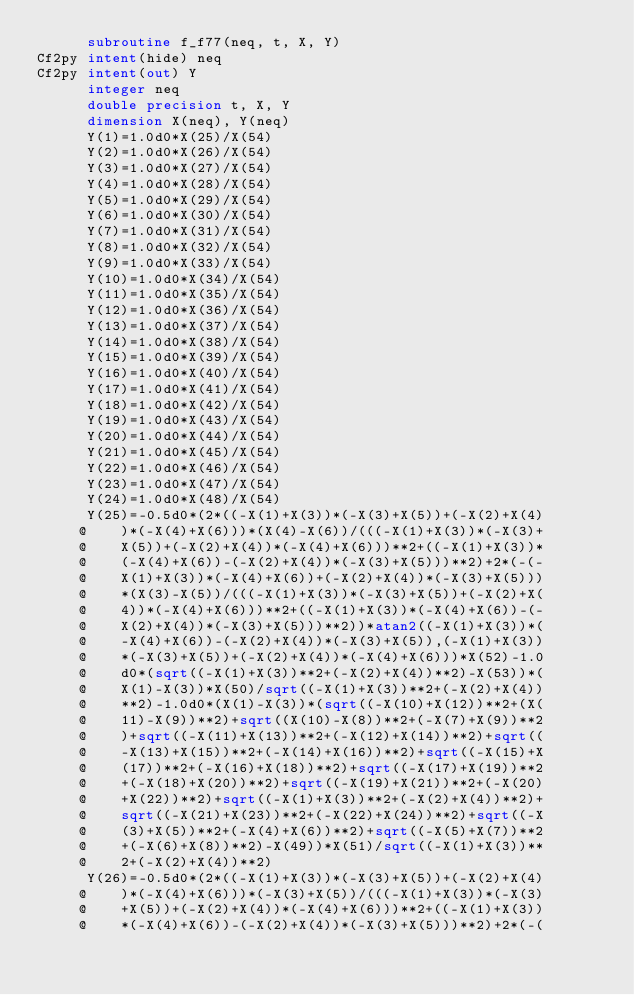<code> <loc_0><loc_0><loc_500><loc_500><_FORTRAN_>      subroutine f_f77(neq, t, X, Y)
Cf2py intent(hide) neq
Cf2py intent(out) Y
      integer neq
      double precision t, X, Y
      dimension X(neq), Y(neq)
      Y(1)=1.0d0*X(25)/X(54)
      Y(2)=1.0d0*X(26)/X(54)
      Y(3)=1.0d0*X(27)/X(54)
      Y(4)=1.0d0*X(28)/X(54)
      Y(5)=1.0d0*X(29)/X(54)
      Y(6)=1.0d0*X(30)/X(54)
      Y(7)=1.0d0*X(31)/X(54)
      Y(8)=1.0d0*X(32)/X(54)
      Y(9)=1.0d0*X(33)/X(54)
      Y(10)=1.0d0*X(34)/X(54)
      Y(11)=1.0d0*X(35)/X(54)
      Y(12)=1.0d0*X(36)/X(54)
      Y(13)=1.0d0*X(37)/X(54)
      Y(14)=1.0d0*X(38)/X(54)
      Y(15)=1.0d0*X(39)/X(54)
      Y(16)=1.0d0*X(40)/X(54)
      Y(17)=1.0d0*X(41)/X(54)
      Y(18)=1.0d0*X(42)/X(54)
      Y(19)=1.0d0*X(43)/X(54)
      Y(20)=1.0d0*X(44)/X(54)
      Y(21)=1.0d0*X(45)/X(54)
      Y(22)=1.0d0*X(46)/X(54)
      Y(23)=1.0d0*X(47)/X(54)
      Y(24)=1.0d0*X(48)/X(54)
      Y(25)=-0.5d0*(2*((-X(1)+X(3))*(-X(3)+X(5))+(-X(2)+X(4)
     @    )*(-X(4)+X(6)))*(X(4)-X(6))/(((-X(1)+X(3))*(-X(3)+
     @    X(5))+(-X(2)+X(4))*(-X(4)+X(6)))**2+((-X(1)+X(3))*
     @    (-X(4)+X(6))-(-X(2)+X(4))*(-X(3)+X(5)))**2)+2*(-(-
     @    X(1)+X(3))*(-X(4)+X(6))+(-X(2)+X(4))*(-X(3)+X(5)))
     @    *(X(3)-X(5))/(((-X(1)+X(3))*(-X(3)+X(5))+(-X(2)+X(
     @    4))*(-X(4)+X(6)))**2+((-X(1)+X(3))*(-X(4)+X(6))-(-
     @    X(2)+X(4))*(-X(3)+X(5)))**2))*atan2((-X(1)+X(3))*(
     @    -X(4)+X(6))-(-X(2)+X(4))*(-X(3)+X(5)),(-X(1)+X(3))
     @    *(-X(3)+X(5))+(-X(2)+X(4))*(-X(4)+X(6)))*X(52)-1.0
     @    d0*(sqrt((-X(1)+X(3))**2+(-X(2)+X(4))**2)-X(53))*(
     @    X(1)-X(3))*X(50)/sqrt((-X(1)+X(3))**2+(-X(2)+X(4))
     @    **2)-1.0d0*(X(1)-X(3))*(sqrt((-X(10)+X(12))**2+(X(
     @    11)-X(9))**2)+sqrt((X(10)-X(8))**2+(-X(7)+X(9))**2
     @    )+sqrt((-X(11)+X(13))**2+(-X(12)+X(14))**2)+sqrt((
     @    -X(13)+X(15))**2+(-X(14)+X(16))**2)+sqrt((-X(15)+X
     @    (17))**2+(-X(16)+X(18))**2)+sqrt((-X(17)+X(19))**2
     @    +(-X(18)+X(20))**2)+sqrt((-X(19)+X(21))**2+(-X(20)
     @    +X(22))**2)+sqrt((-X(1)+X(3))**2+(-X(2)+X(4))**2)+
     @    sqrt((-X(21)+X(23))**2+(-X(22)+X(24))**2)+sqrt((-X
     @    (3)+X(5))**2+(-X(4)+X(6))**2)+sqrt((-X(5)+X(7))**2
     @    +(-X(6)+X(8))**2)-X(49))*X(51)/sqrt((-X(1)+X(3))**
     @    2+(-X(2)+X(4))**2)
      Y(26)=-0.5d0*(2*((-X(1)+X(3))*(-X(3)+X(5))+(-X(2)+X(4)
     @    )*(-X(4)+X(6)))*(-X(3)+X(5))/(((-X(1)+X(3))*(-X(3)
     @    +X(5))+(-X(2)+X(4))*(-X(4)+X(6)))**2+((-X(1)+X(3))
     @    *(-X(4)+X(6))-(-X(2)+X(4))*(-X(3)+X(5)))**2)+2*(-(</code> 